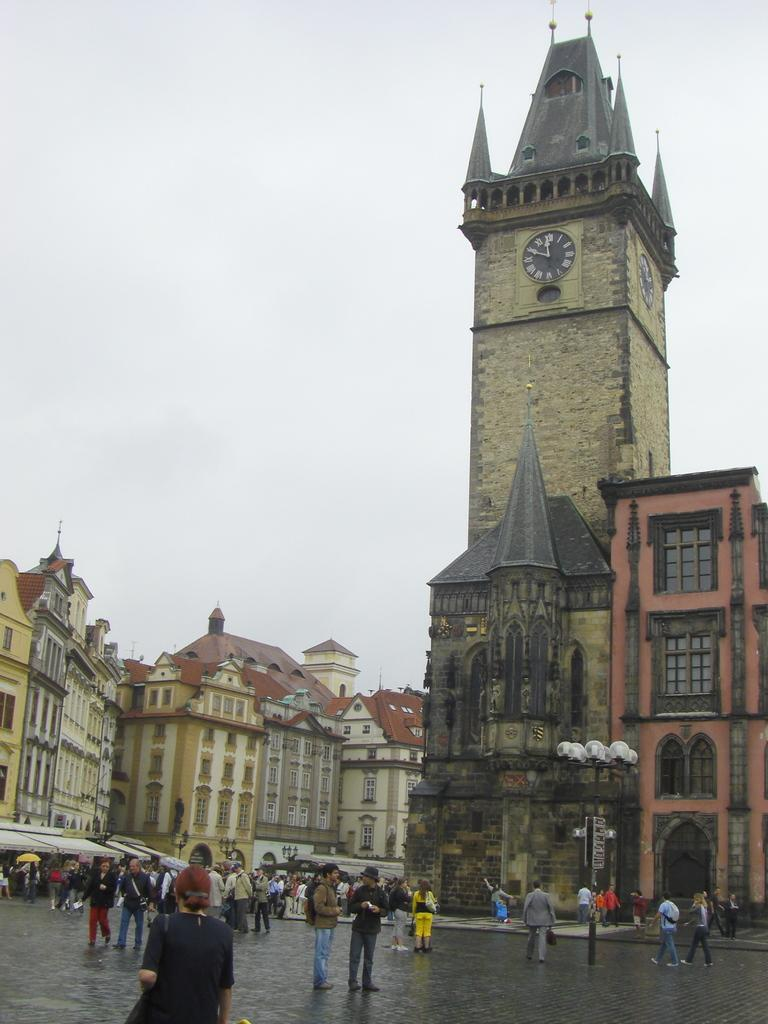What is happening on the land in the image? There are many people standing on the land in the image. What can be seen in the distance behind the people? There are buildings and castles in the background of the image. What is visible above the people and structures in the image? The sky is visible in the image. What type of quiver can be seen in the hands of the people in the image? There is no quiver present in the image; the people are not holding any such objects. Can you tell me which person in the image is displaying the most anger? There is no indication of anger or any specific emotions in the image; the people are simply standing on the land. 